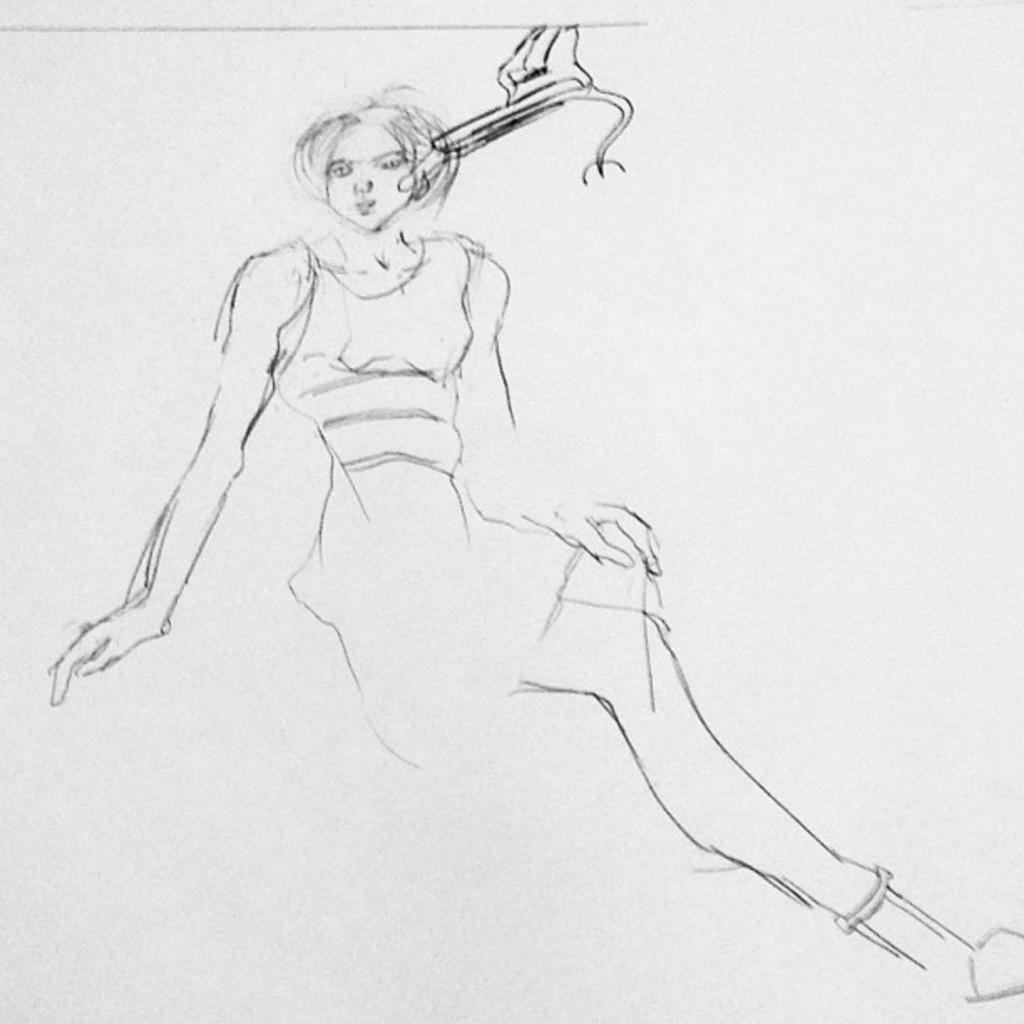What is present in the image? There is a paper in the image. What is depicted on the paper? The paper contains a sketch of a woman. Where is the sketch of the woman located on the paper? The sketch of the woman is in the middle of the image. What type of brass instrument is being played by the woman in the sketch? There is no brass instrument or woman playing an instrument in the image; it only contains a sketch of a woman. 